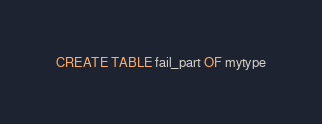<code> <loc_0><loc_0><loc_500><loc_500><_SQL_>CREATE TABLE fail_part OF mytype
</code> 